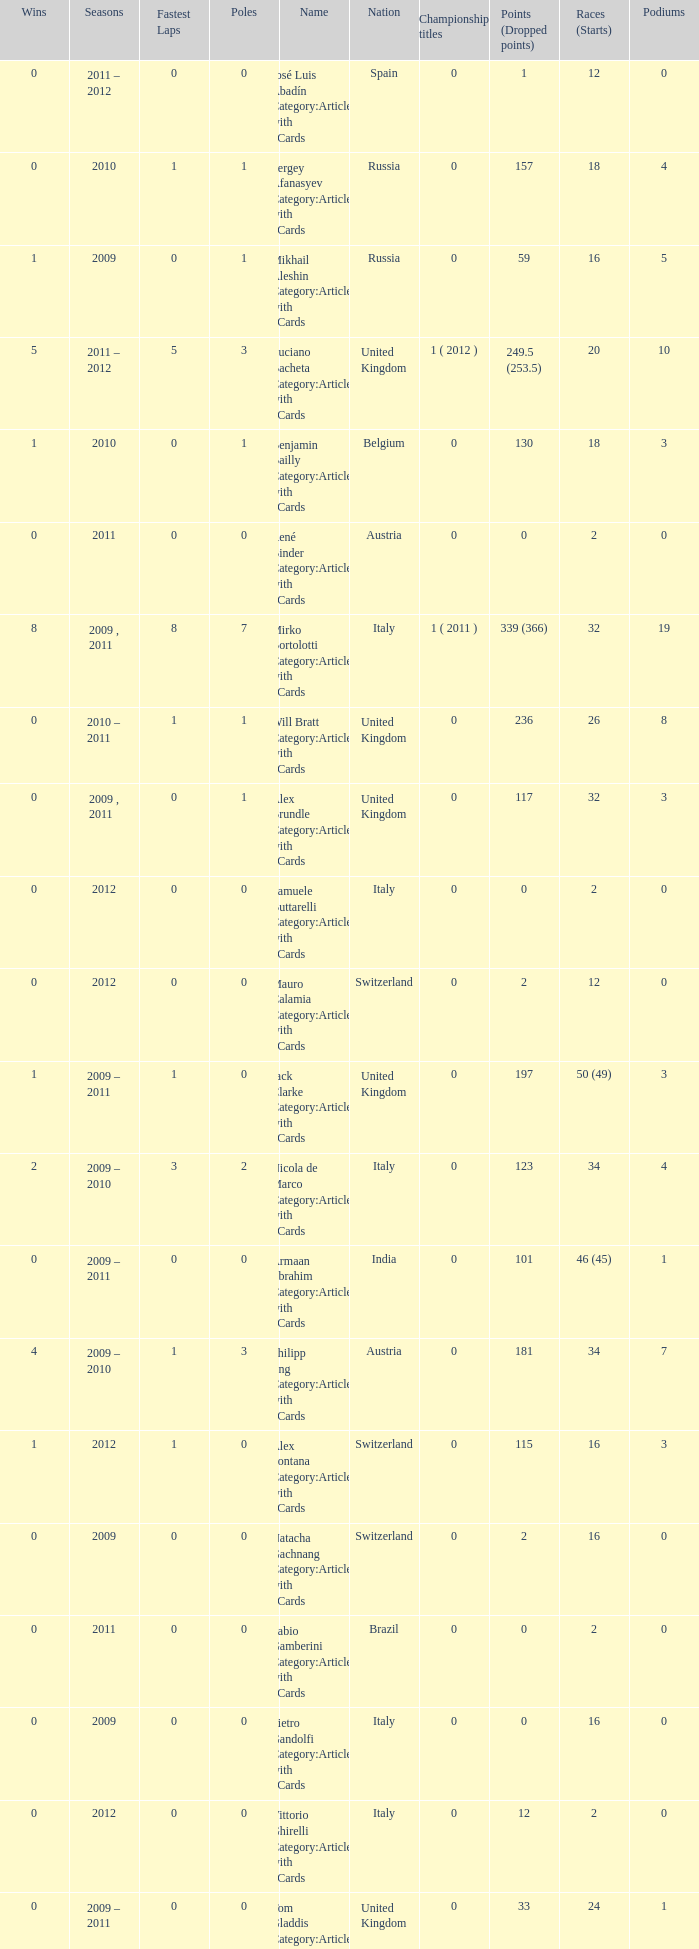What is the minimum amount of poles? 0.0. 